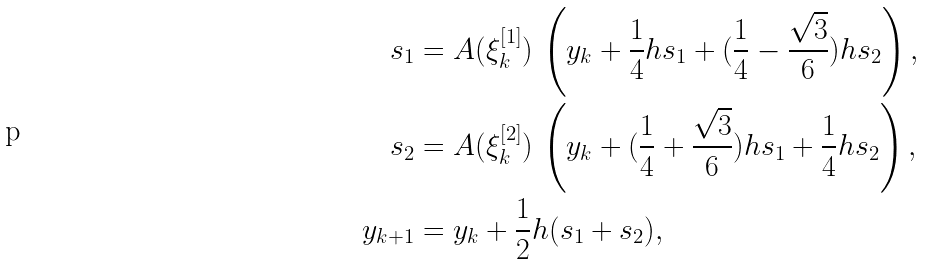<formula> <loc_0><loc_0><loc_500><loc_500>s _ { 1 } & = A ( \xi _ { k } ^ { [ 1 ] } ) \, \left ( y _ { k } + \frac { 1 } { 4 } h s _ { 1 } + ( \frac { 1 } { 4 } - \frac { \sqrt { 3 } } 6 ) h s _ { 2 } \right ) , \\ s _ { 2 } & = A ( \xi _ { k } ^ { [ 2 ] } ) \, \left ( y _ { k } + ( \frac { 1 } { 4 } + \frac { \sqrt { 3 } } 6 ) h s _ { 1 } + \frac { 1 } { 4 } h s _ { 2 } \right ) , \\ y _ { k + 1 } & = y _ { k } + \frac { 1 } { 2 } h ( s _ { 1 } + s _ { 2 } ) ,</formula> 